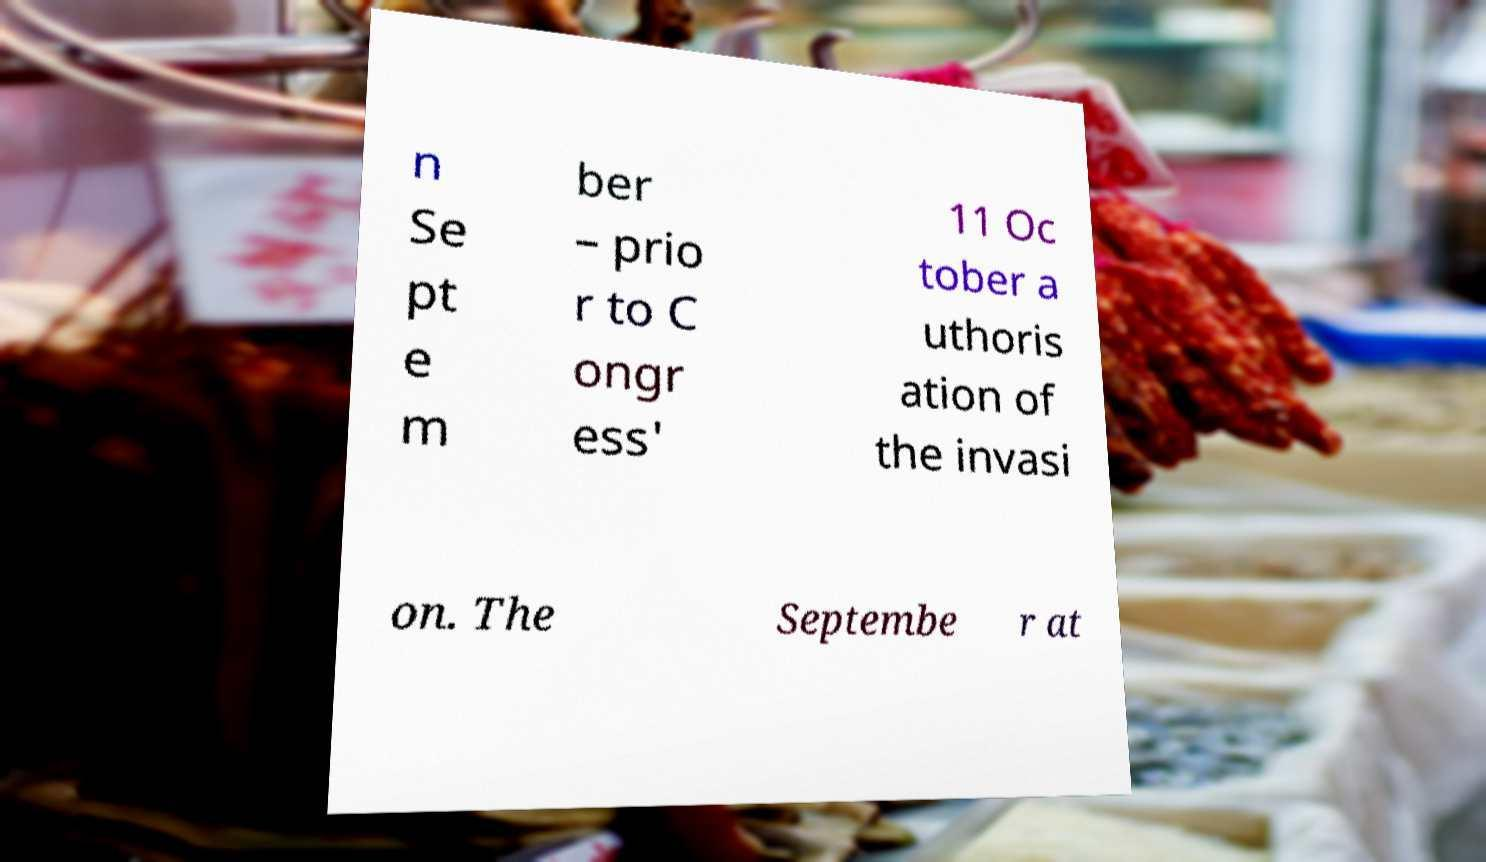Can you accurately transcribe the text from the provided image for me? n Se pt e m ber – prio r to C ongr ess' 11 Oc tober a uthoris ation of the invasi on. The Septembe r at 